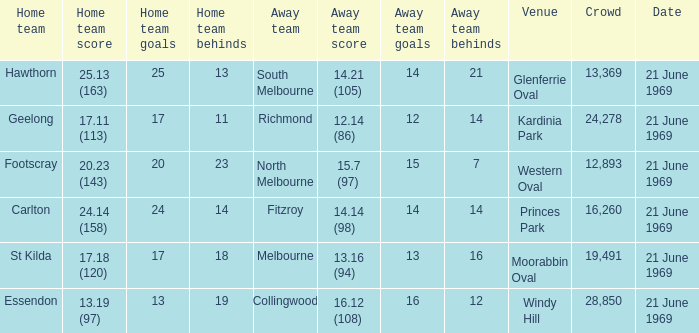What is Essendon's home team that has an away crowd size larger than 19,491? Collingwood. 